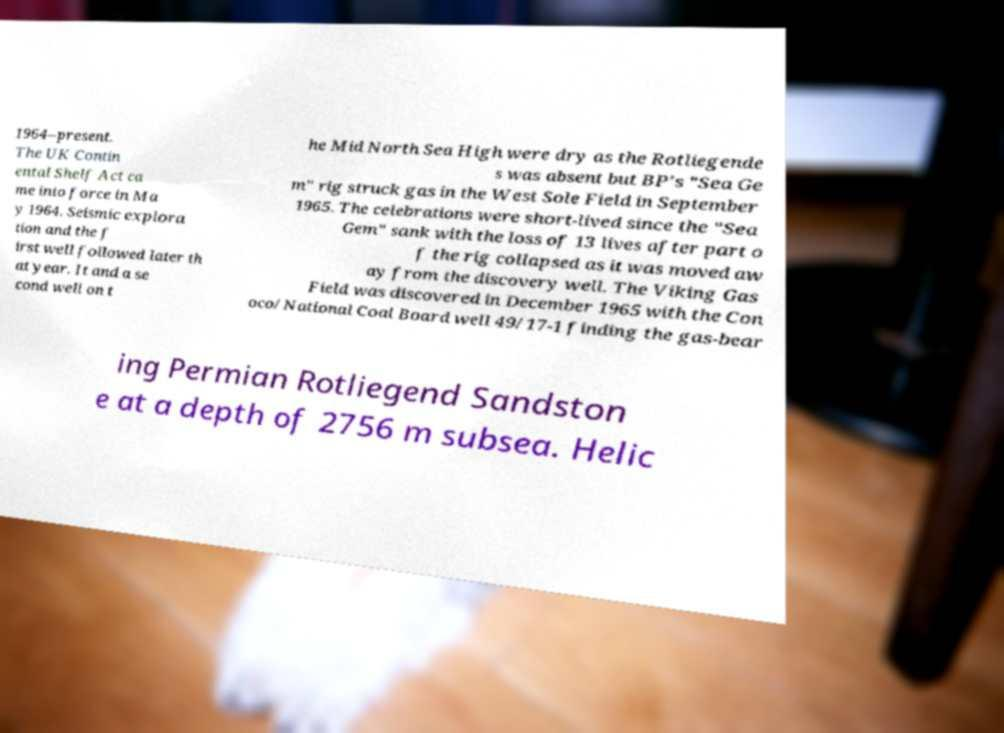I need the written content from this picture converted into text. Can you do that? 1964–present. The UK Contin ental Shelf Act ca me into force in Ma y 1964. Seismic explora tion and the f irst well followed later th at year. It and a se cond well on t he Mid North Sea High were dry as the Rotliegende s was absent but BP's "Sea Ge m" rig struck gas in the West Sole Field in September 1965. The celebrations were short-lived since the "Sea Gem" sank with the loss of 13 lives after part o f the rig collapsed as it was moved aw ay from the discovery well. The Viking Gas Field was discovered in December 1965 with the Con oco/National Coal Board well 49/17-1 finding the gas-bear ing Permian Rotliegend Sandston e at a depth of 2756 m subsea. Helic 